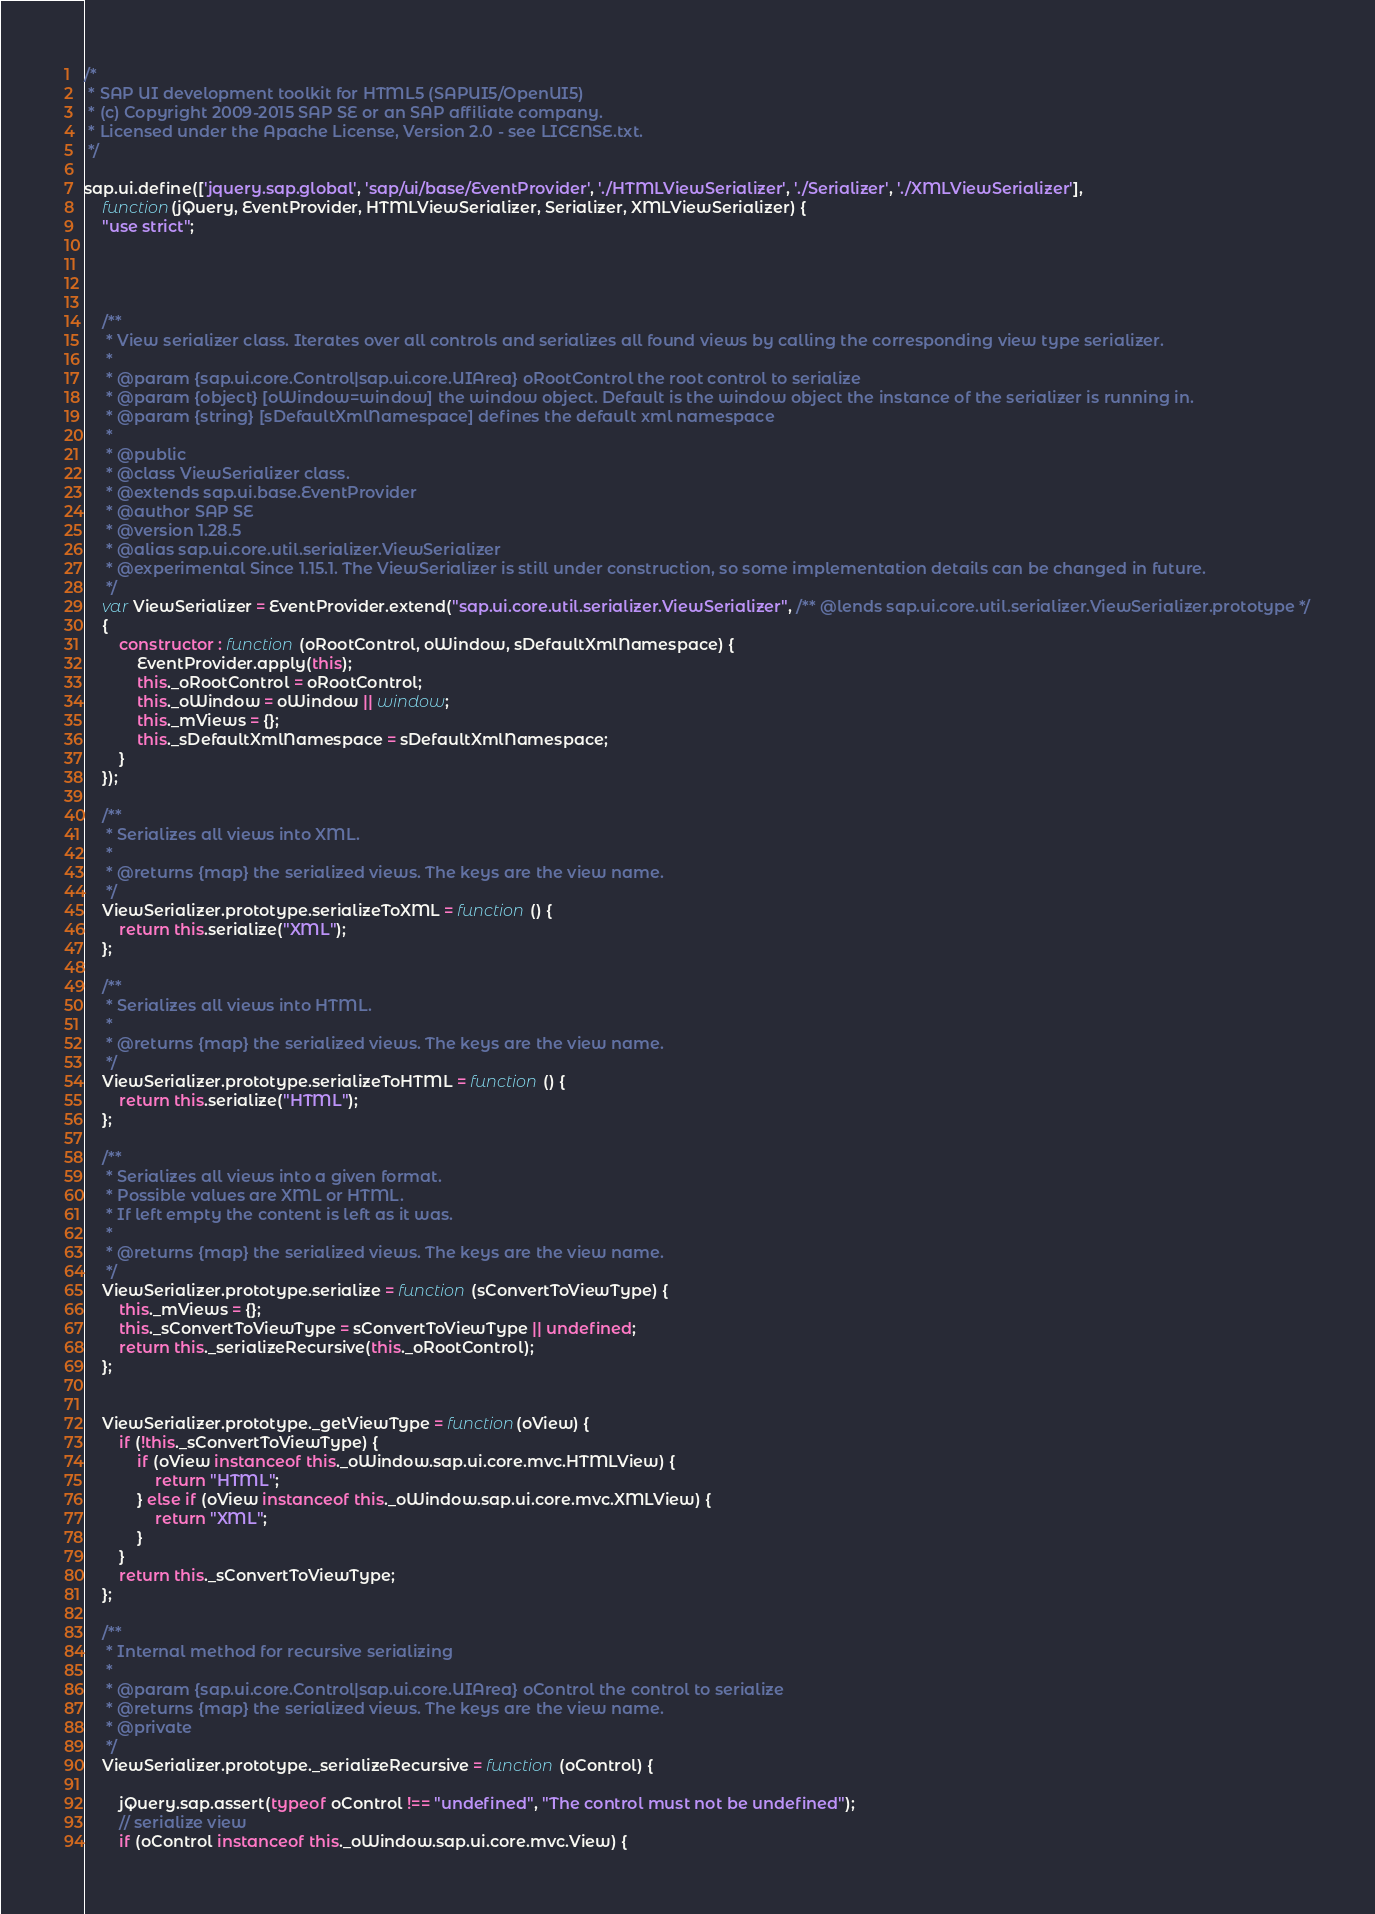Convert code to text. <code><loc_0><loc_0><loc_500><loc_500><_JavaScript_>/*
 * SAP UI development toolkit for HTML5 (SAPUI5/OpenUI5)
 * (c) Copyright 2009-2015 SAP SE or an SAP affiliate company.
 * Licensed under the Apache License, Version 2.0 - see LICENSE.txt.
 */

sap.ui.define(['jquery.sap.global', 'sap/ui/base/EventProvider', './HTMLViewSerializer', './Serializer', './XMLViewSerializer'],
	function(jQuery, EventProvider, HTMLViewSerializer, Serializer, XMLViewSerializer) {
	"use strict";


	
	
	/**
	 * View serializer class. Iterates over all controls and serializes all found views by calling the corresponding view type serializer.
	 *
	 * @param {sap.ui.core.Control|sap.ui.core.UIArea} oRootControl the root control to serialize
	 * @param {object} [oWindow=window] the window object. Default is the window object the instance of the serializer is running in.
	 * @param {string} [sDefaultXmlNamespace] defines the default xml namespace
	 *
	 * @public
	 * @class ViewSerializer class.
	 * @extends sap.ui.base.EventProvider
	 * @author SAP SE
	 * @version 1.28.5
	 * @alias sap.ui.core.util.serializer.ViewSerializer
	 * @experimental Since 1.15.1. The ViewSerializer is still under construction, so some implementation details can be changed in future.
	 */
	var ViewSerializer = EventProvider.extend("sap.ui.core.util.serializer.ViewSerializer", /** @lends sap.ui.core.util.serializer.ViewSerializer.prototype */
	{
		constructor : function (oRootControl, oWindow, sDefaultXmlNamespace) {
			EventProvider.apply(this);
			this._oRootControl = oRootControl;
			this._oWindow = oWindow || window;
			this._mViews = {};
			this._sDefaultXmlNamespace = sDefaultXmlNamespace;
		}
	});
	
	/**
	 * Serializes all views into XML.
	 * 
	 * @returns {map} the serialized views. The keys are the view name.
	 */
	ViewSerializer.prototype.serializeToXML = function () {
		return this.serialize("XML");
	};
	
	/**
	 * Serializes all views into HTML.
	 * 
	 * @returns {map} the serialized views. The keys are the view name.
	 */
	ViewSerializer.prototype.serializeToHTML = function () {
		return this.serialize("HTML");
	};
	
	/**
	 * Serializes all views into a given format.
	 * Possible values are XML or HTML.  
	 * If left empty the content is left as it was.
	 * 
	 * @returns {map} the serialized views. The keys are the view name.
	 */
	ViewSerializer.prototype.serialize = function (sConvertToViewType) {
		this._mViews = {};
		this._sConvertToViewType = sConvertToViewType || undefined;
		return this._serializeRecursive(this._oRootControl);
	};
	
	
	ViewSerializer.prototype._getViewType = function(oView) {
		if (!this._sConvertToViewType) {
			if (oView instanceof this._oWindow.sap.ui.core.mvc.HTMLView) {
				return "HTML";
			} else if (oView instanceof this._oWindow.sap.ui.core.mvc.XMLView) {
				return "XML";
			}
		}
		return this._sConvertToViewType;
	};
	
	/**
	 * Internal method for recursive serializing
	 * 
	 * @param {sap.ui.core.Control|sap.ui.core.UIArea} oControl the control to serialize
	 * @returns {map} the serialized views. The keys are the view name.
	 * @private
	 */
	ViewSerializer.prototype._serializeRecursive = function (oControl) {
	
		jQuery.sap.assert(typeof oControl !== "undefined", "The control must not be undefined");
		// serialize view
		if (oControl instanceof this._oWindow.sap.ui.core.mvc.View) {</code> 